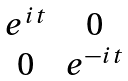<formula> <loc_0><loc_0><loc_500><loc_500>\begin{matrix} e ^ { i { t } } & 0 \\ 0 & e ^ { - i { t } } \end{matrix}</formula> 